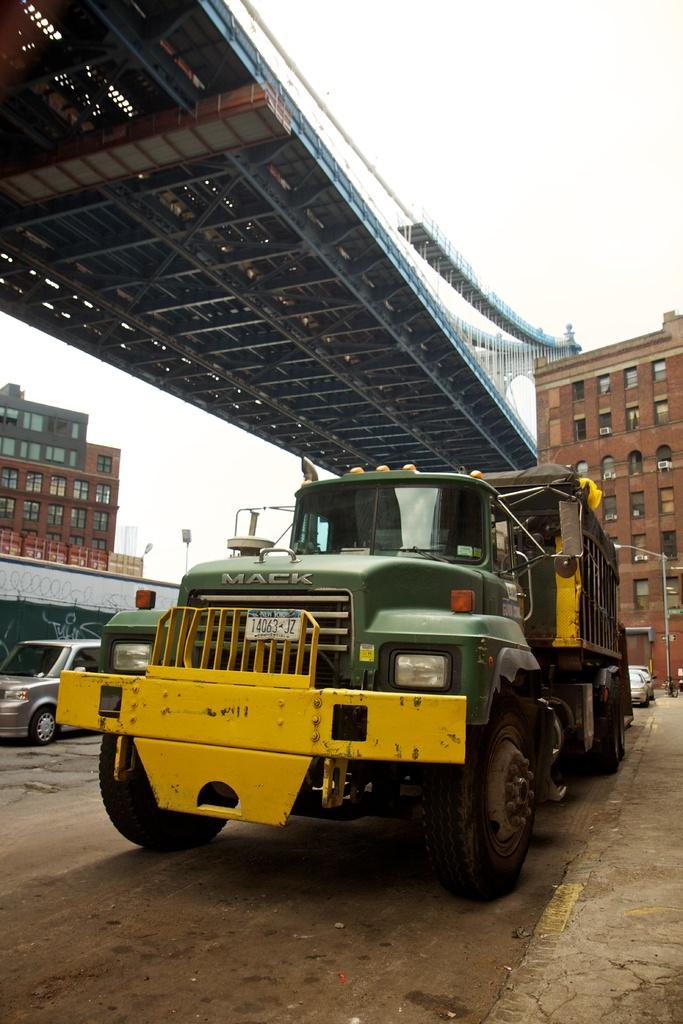What type of truck is this?
Provide a short and direct response. Mack. What is the plate number?
Offer a very short reply. 14063 jz. 